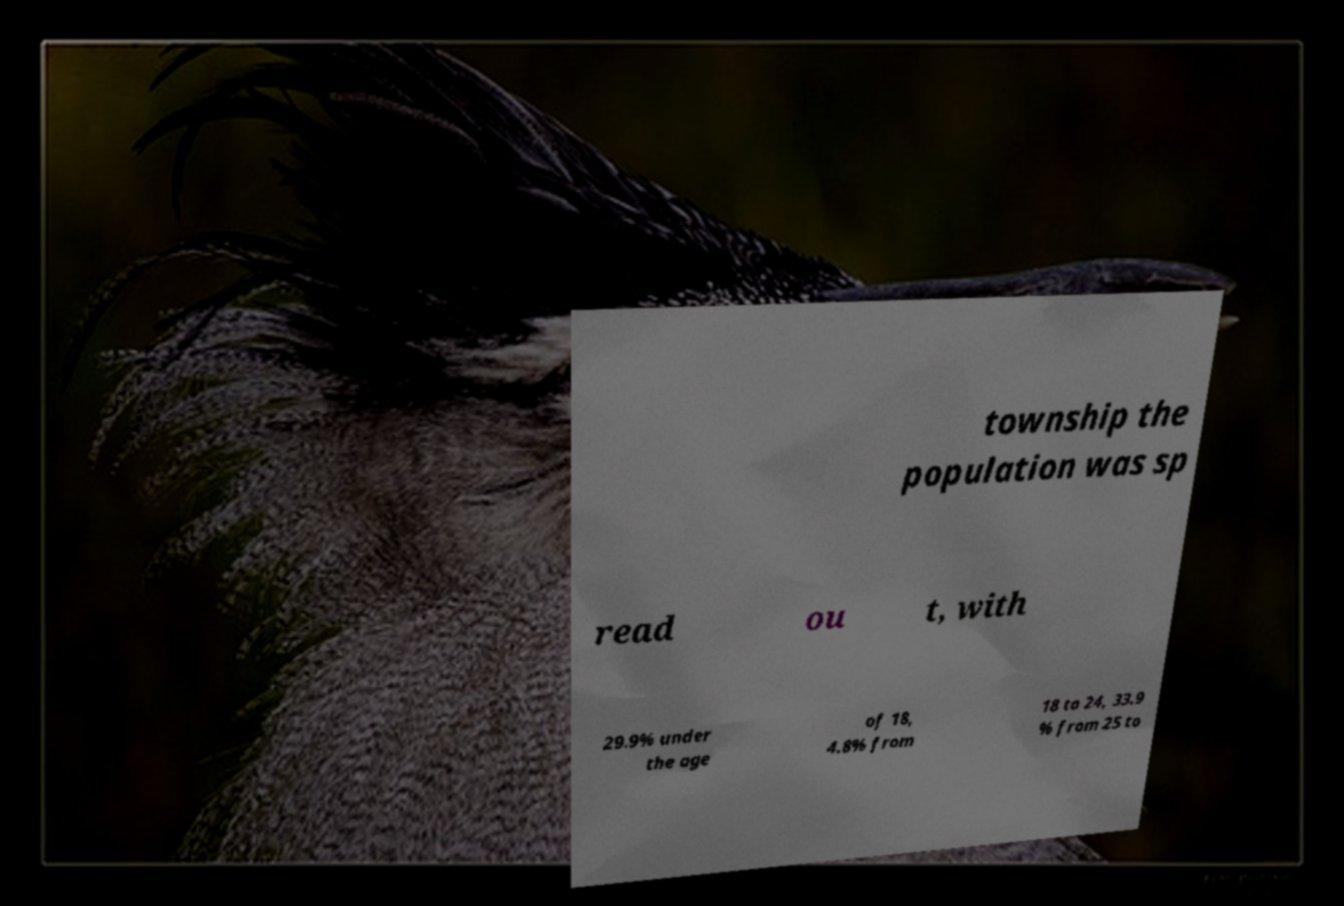Could you extract and type out the text from this image? township the population was sp read ou t, with 29.9% under the age of 18, 4.8% from 18 to 24, 33.9 % from 25 to 